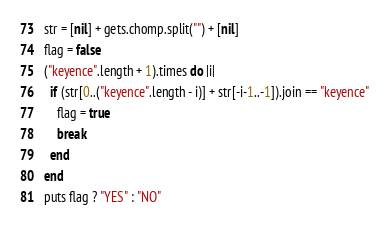Convert code to text. <code><loc_0><loc_0><loc_500><loc_500><_Ruby_>str = [nil] + gets.chomp.split("") + [nil]
flag = false
("keyence".length + 1).times do |i|
  if (str[0..("keyence".length - i)] + str[-i-1..-1]).join == "keyence"
    flag = true
    break
  end
end
puts flag ? "YES" : "NO"
</code> 